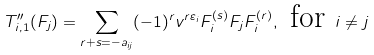Convert formula to latex. <formula><loc_0><loc_0><loc_500><loc_500>T _ { i , 1 } ^ { \prime \prime } ( F _ { j } ) = \sum _ { r + s = - a _ { i j } } ( - 1 ) ^ { r } v ^ { r \varepsilon _ { i } } F _ { i } ^ { ( s ) } F _ { j } F _ { i } ^ { ( r ) } , \text { for } i \neq j</formula> 